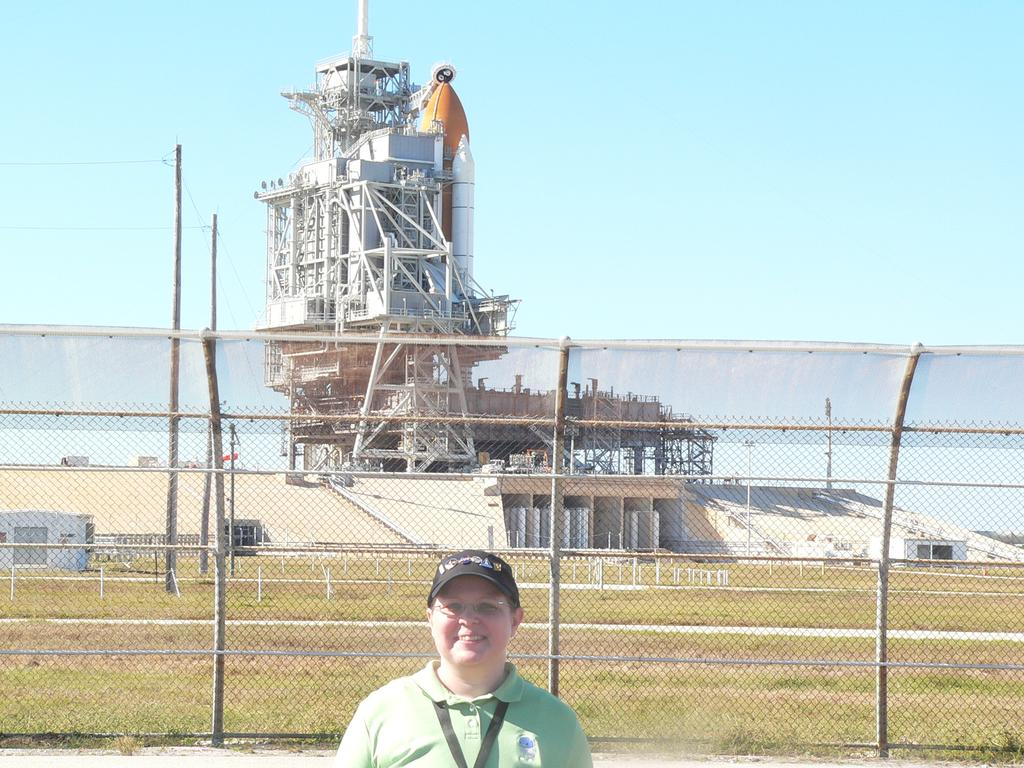What is the person in the image doing? The person is standing beside the fence. What can be seen in the background of the image? There is a building with windows, grass, a construction tower, and the sky visible in the background. What type of cup is the person holding in the image? There is no cup present in the image. What is the person doing to themselves in the image? There is no indication of the person performing any action on themselves in the image. 